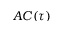<formula> <loc_0><loc_0><loc_500><loc_500>A C ( \tau )</formula> 